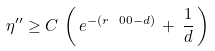Convert formula to latex. <formula><loc_0><loc_0><loc_500><loc_500>\eta ^ { \prime \prime } \geq C \, \left ( \, e ^ { - ( r \ 0 { 0 } - d ) } \, + \, \frac { 1 } { d } \, \right )</formula> 